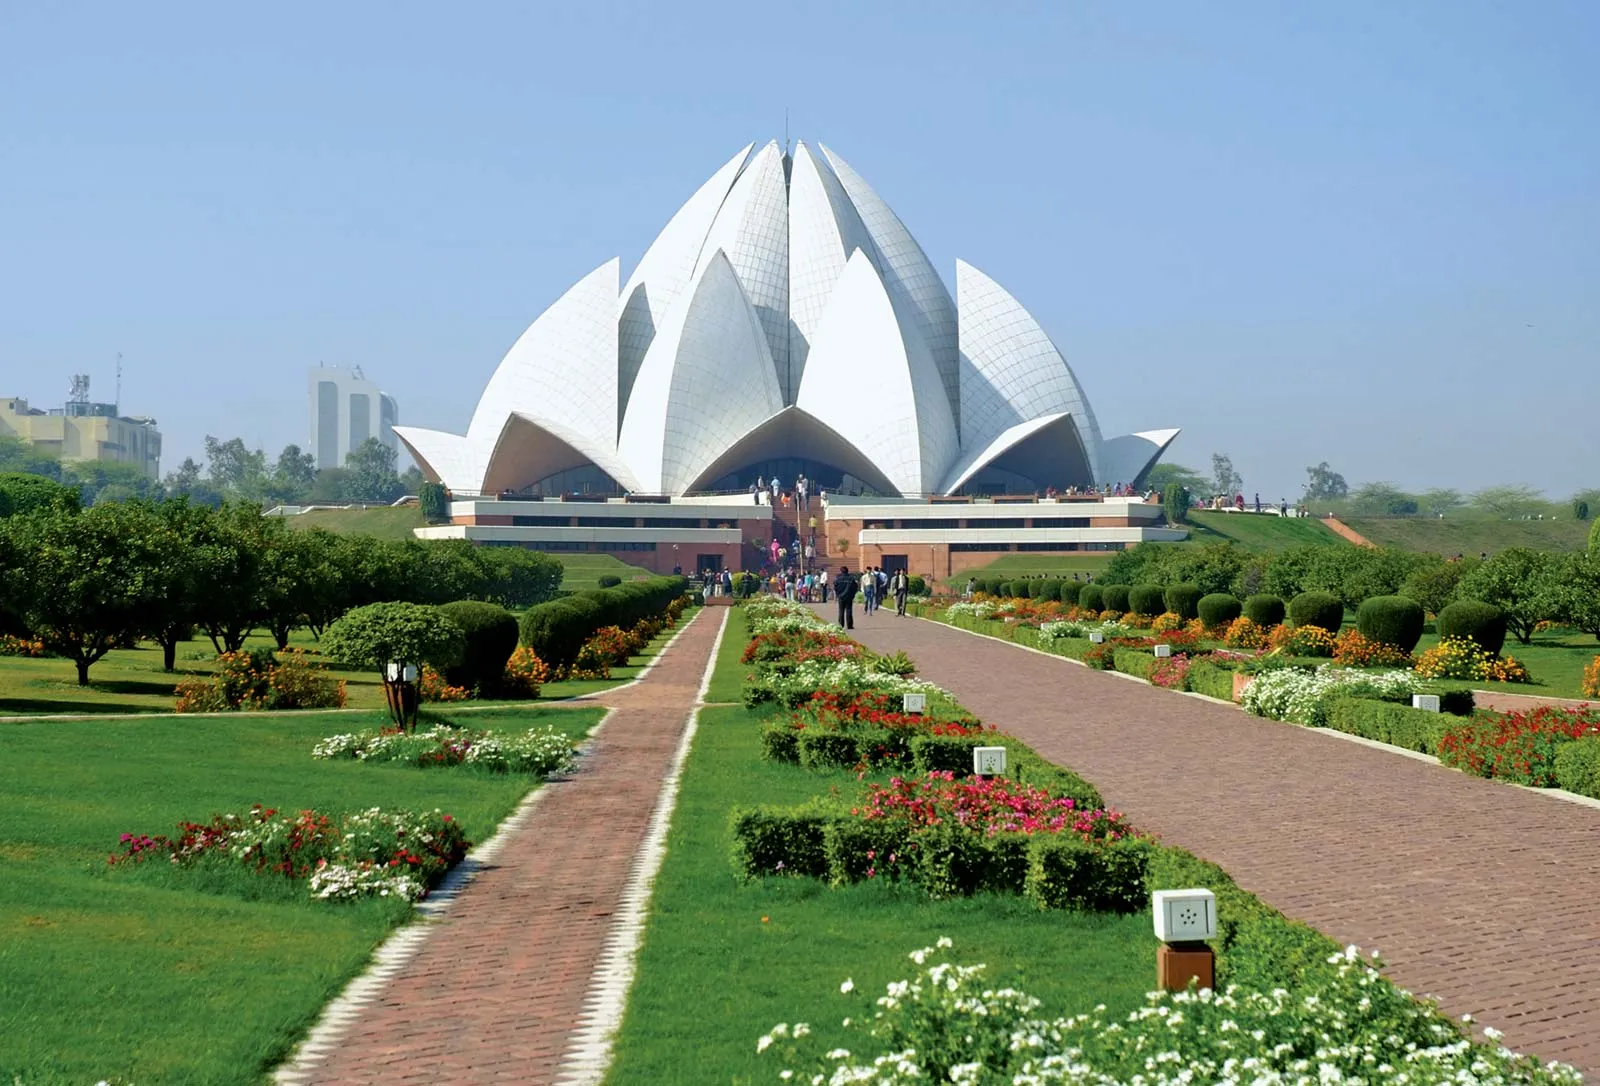What influences did the Bahá'í faith have on the design of the Lotus Temple? The design of the Lotus Temple is heavily influenced by Bahá'í principles, which emphasize unity, equality, and harmony among all religions and people. The choice of a lotus flower for the design symbolizes these values as the lotus is a sacred symbol in many religions including Hinduism, Buddhism, and Jainism. This universal symbol helps underline the Bahá'í teaching that religion is a single, organic unity. The temple's structure, which opens towards all directions, symbolically welcomes people from all walks of life, irrespective of their religious backgrounds. This architectural embodiment of inclusivity reflects the Bahá'í faith's dedication to fostering global unity. 